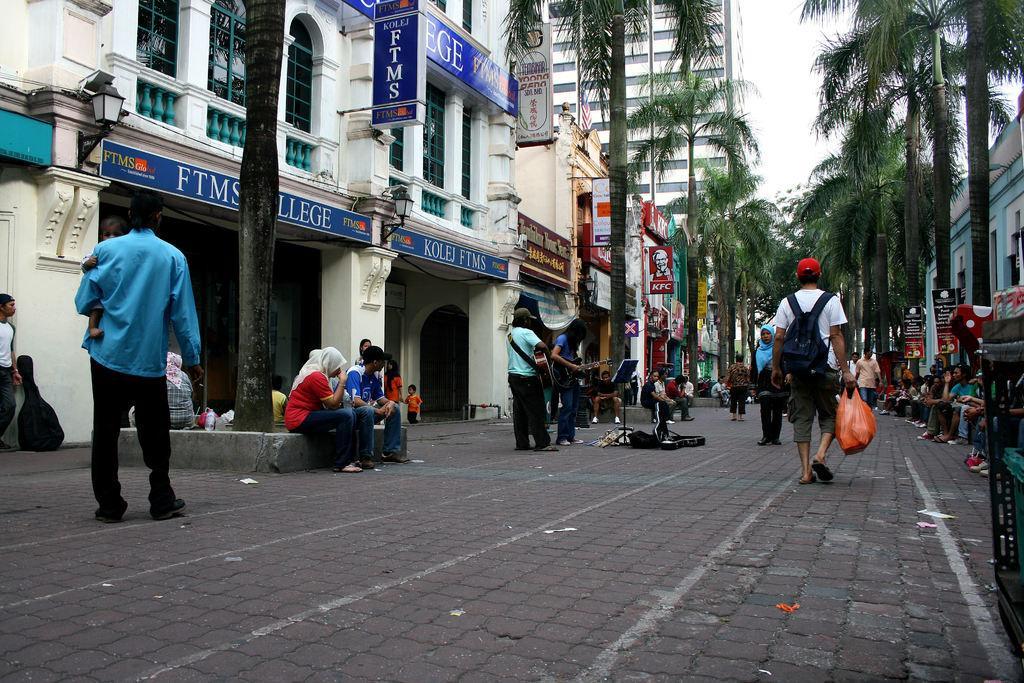Could you give a brief overview of what you see in this image? In this image, we can see some people sitting and there are some people walking, there are some trees, we can see some buildings, there is a sky. 